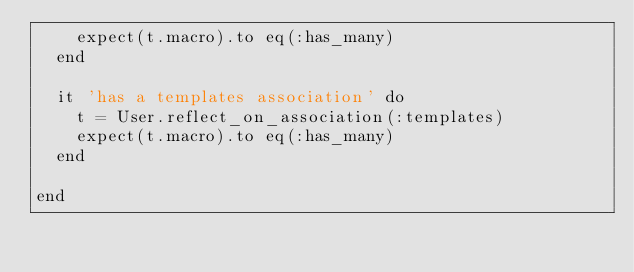Convert code to text. <code><loc_0><loc_0><loc_500><loc_500><_Ruby_>    expect(t.macro).to eq(:has_many)
  end

  it 'has a templates association' do
    t = User.reflect_on_association(:templates)
    expect(t.macro).to eq(:has_many)
  end

end</code> 